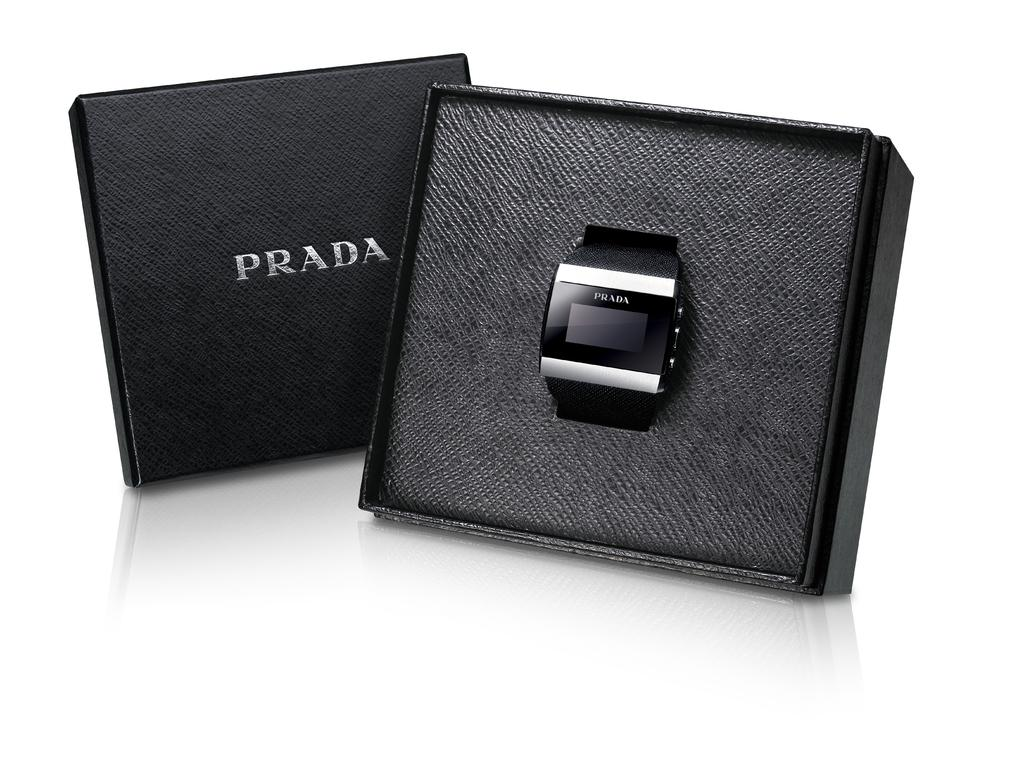<image>
Summarize the visual content of the image. Black and gray box which has a watch and says PRADA on it. 